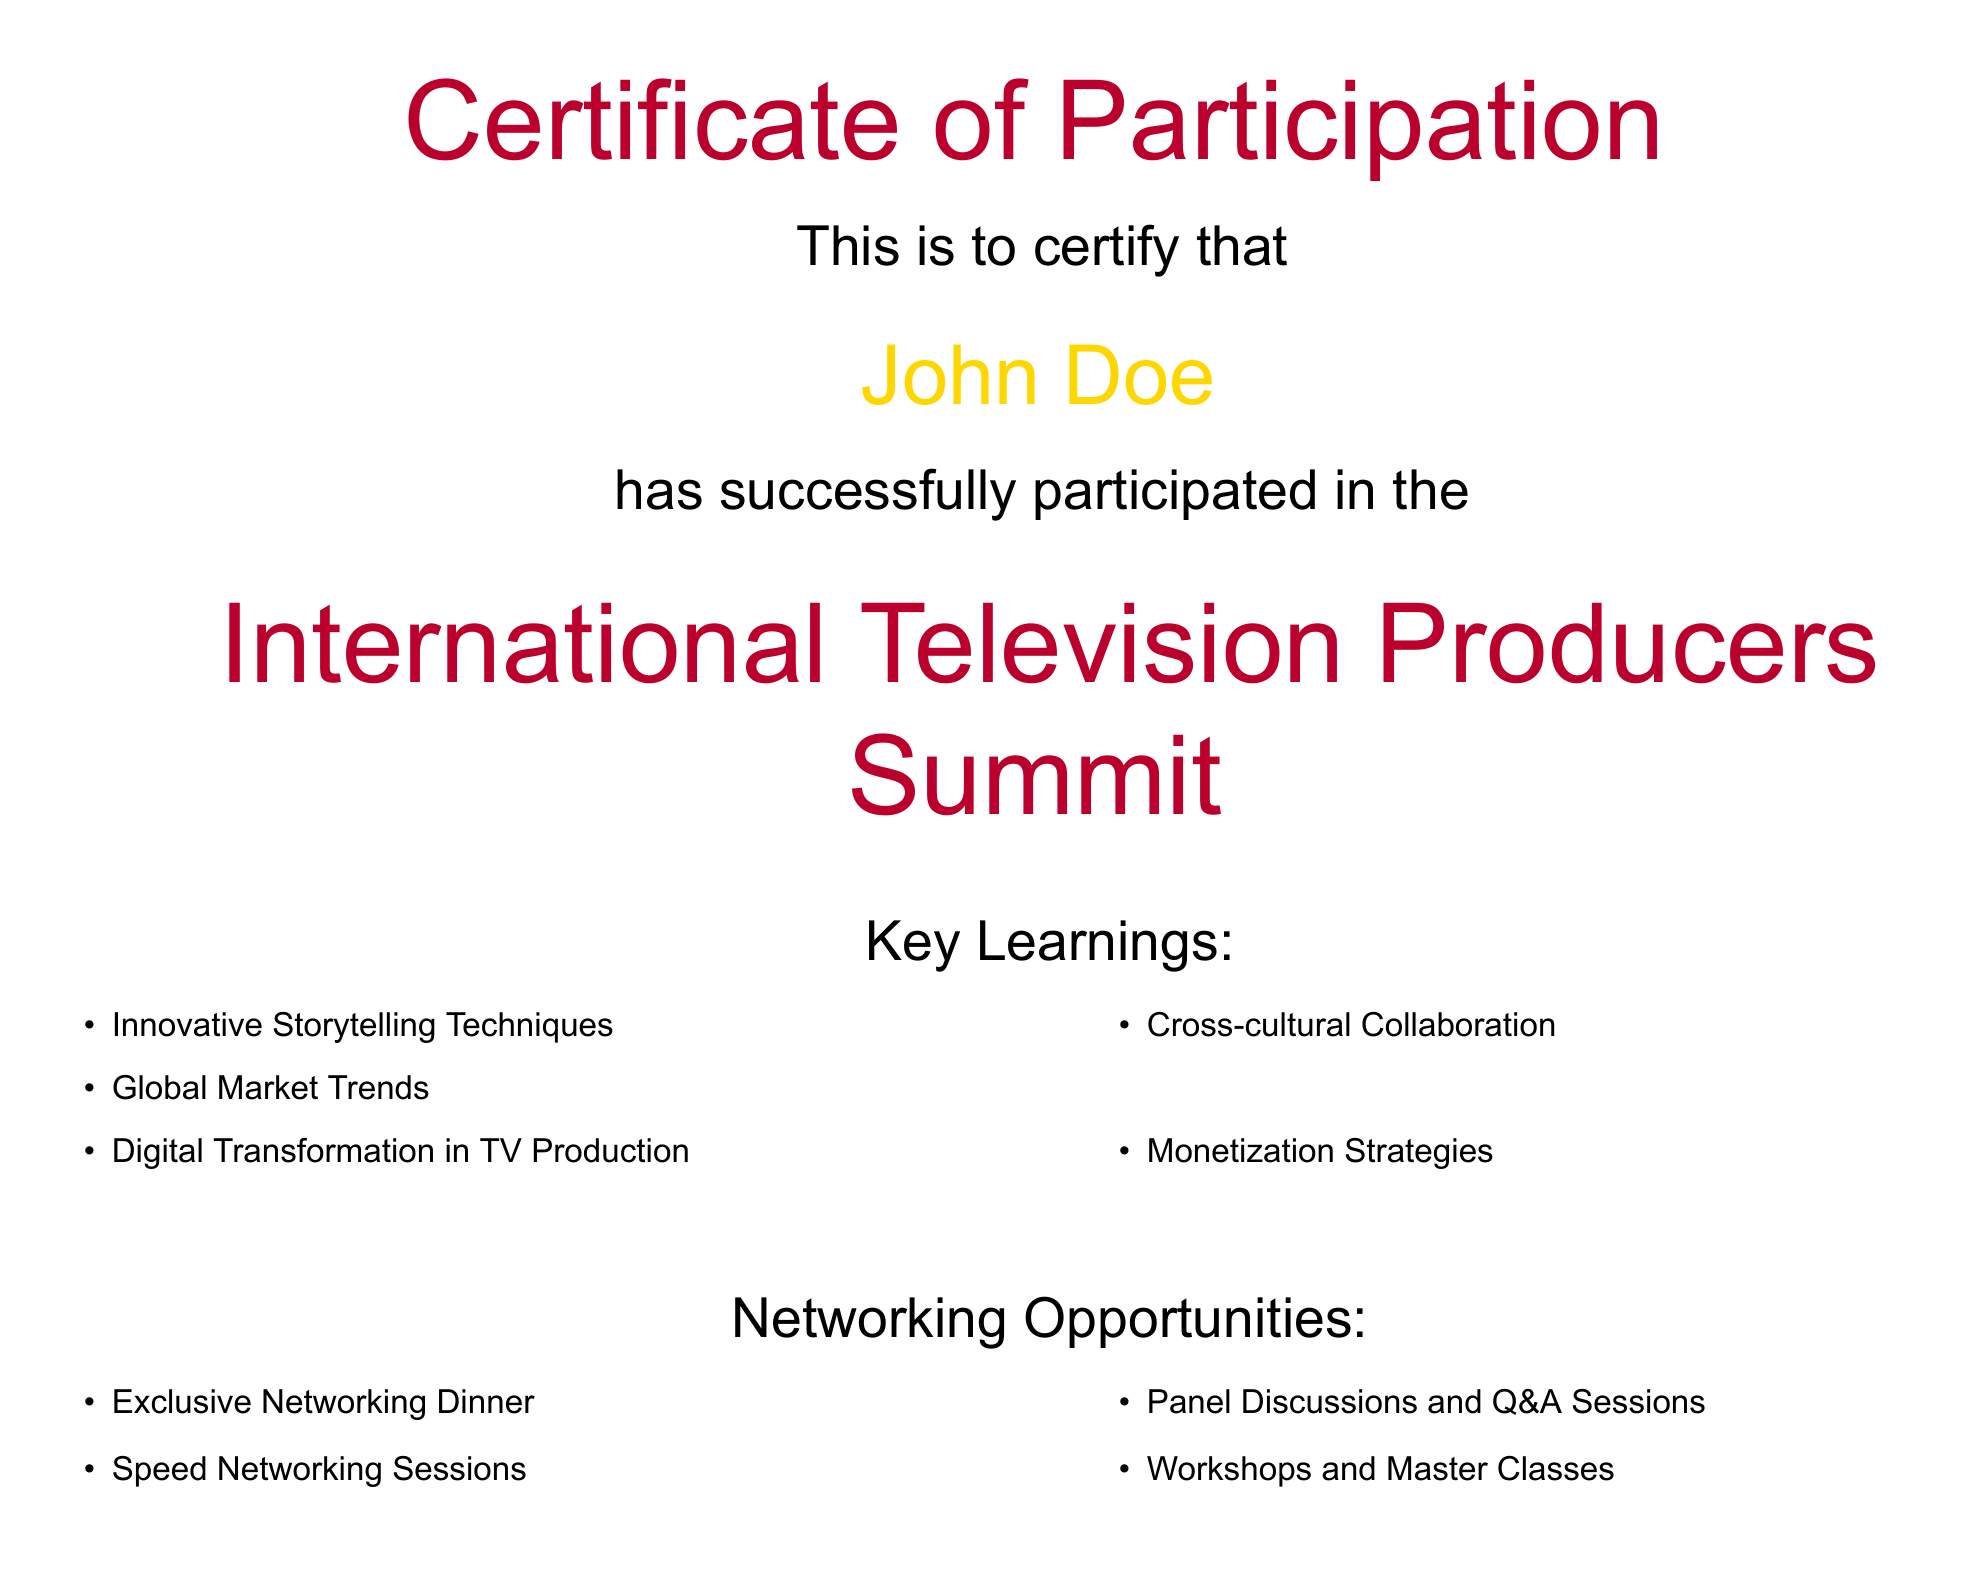What is the participant's name? The participant's name is prominently displayed in the document under the certification statement.
Answer: John Doe What event does this certificate pertain to? The title of the event is highlighted in large font in the center of the document, indicating the nature of the participation.
Answer: International Television Producers Summit What are two key learnings from the summit? The key learnings are listed in a bulleted format under the "Key Learnings" section, showcasing various insights from the summit.
Answer: Innovative Storytelling Techniques, Global Market Trends How many networking opportunities are listed? The document includes several items listed under networking opportunities, and counting them provides the total number of options available to the participant.
Answer: Four What kind of event does the certificate highlight regarding participant engagement? The document describes the nature of the event's discussions and interactions, indicating the importance of participant involvement in shaping the future of television production.
Answer: Cutting-edge discussions What date is mentioned at the bottom of the document? The date is presented in a specific location on the certificate, signifying when the certificate was generated.
Answer: Today 